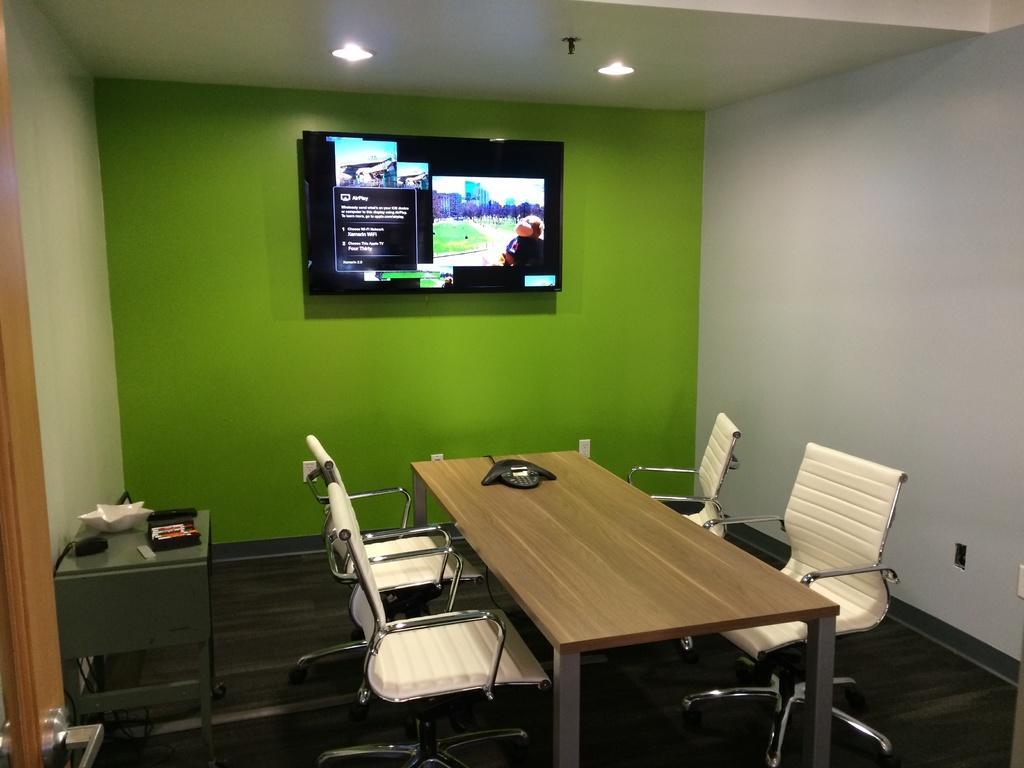How would you summarize this image in a sentence or two? In this image we can see the inner view of a room. At the top of the room there is a television to the wall and electric lights attached to the roof. At the bottom of the roof we can see a side table, a table, telephone, chairs and electric cables. 